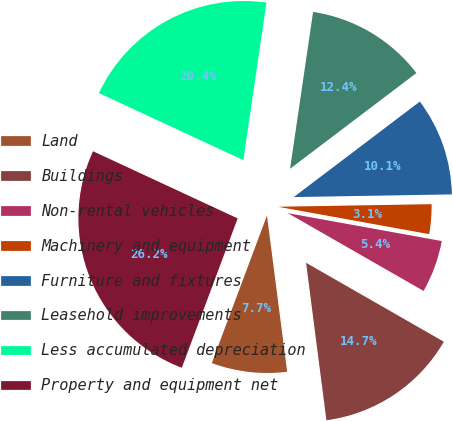Convert chart. <chart><loc_0><loc_0><loc_500><loc_500><pie_chart><fcel>Land<fcel>Buildings<fcel>Non-rental vehicles<fcel>Machinery and equipment<fcel>Furniture and fixtures<fcel>Leasehold improvements<fcel>Less accumulated depreciation<fcel>Property and equipment net<nl><fcel>7.74%<fcel>14.67%<fcel>5.43%<fcel>3.12%<fcel>10.05%<fcel>12.36%<fcel>20.4%<fcel>26.22%<nl></chart> 